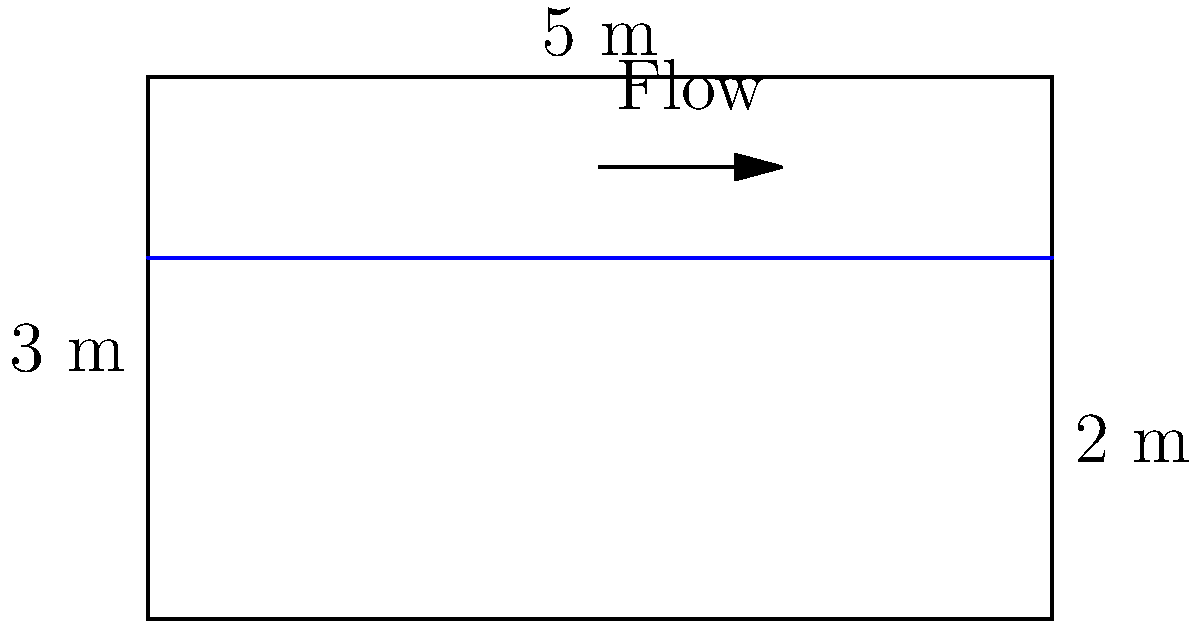A rectangular open channel has a width of 5 m and a depth of 3 m. If the water depth in the channel is 2 m and the average velocity of flow is 1.5 m/s, calculate the flow rate in the channel in cubic meters per second (m³/s). To determine the flow rate in an open channel, we need to use the continuity equation:

$$Q = A \times v$$

Where:
$Q$ = Flow rate (m³/s)
$A$ = Cross-sectional area of flow (m²)
$v$ = Average velocity of flow (m/s)

Step 1: Calculate the cross-sectional area of flow
The cross-sectional area is rectangular, so we multiply the width by the water depth:
$$A = \text{width} \times \text{water depth}$$
$$A = 5 \text{ m} \times 2 \text{ m} = 10 \text{ m}^2$$

Step 2: Use the given average velocity
The average velocity is given as 1.5 m/s.

Step 3: Apply the continuity equation
$$Q = A \times v$$
$$Q = 10 \text{ m}^2 \times 1.5 \text{ m/s}$$
$$Q = 15 \text{ m}^3/\text{s}$$

Therefore, the flow rate in the channel is 15 cubic meters per second.
Answer: 15 m³/s 